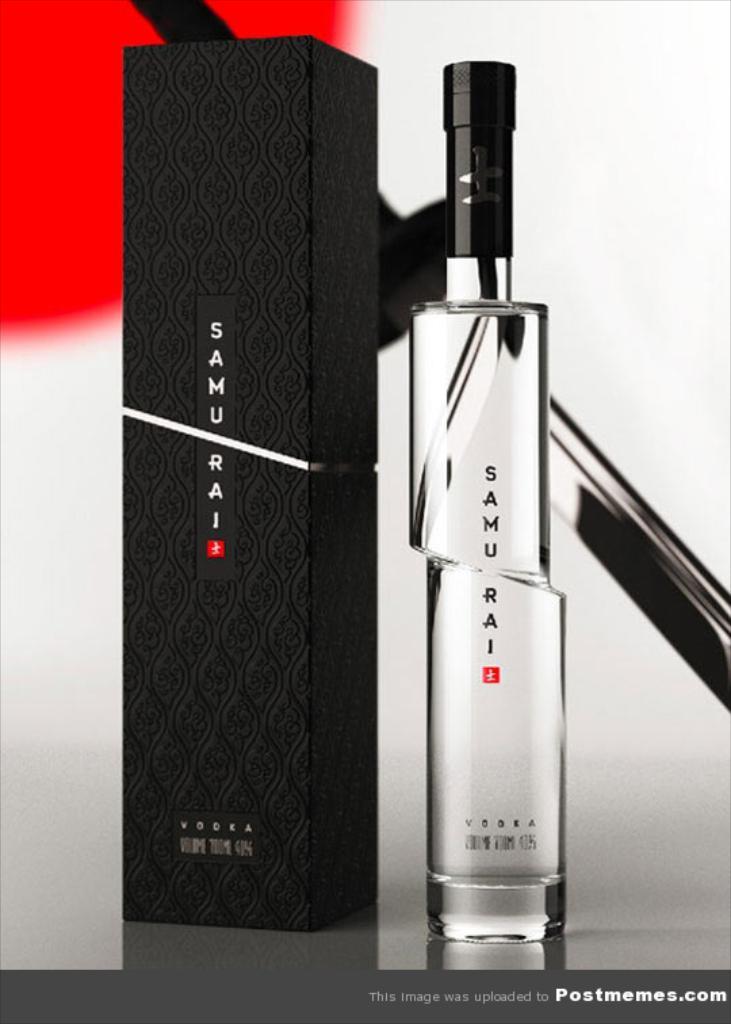What is the name of perfume?
Provide a succinct answer. Samurai. 